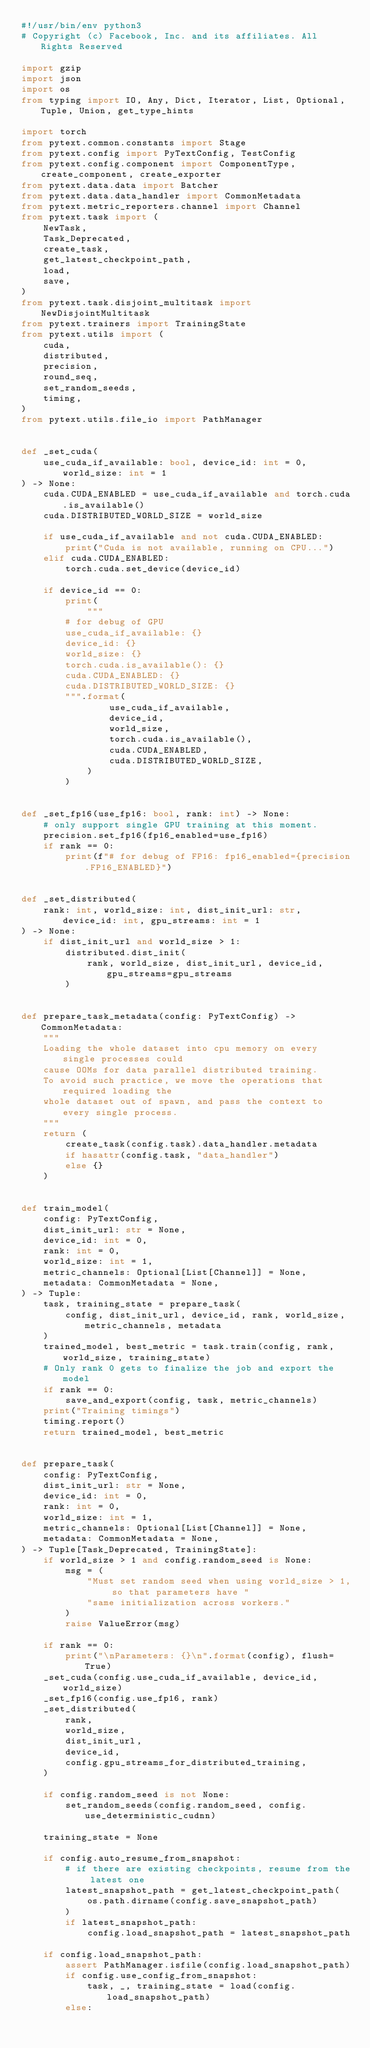Convert code to text. <code><loc_0><loc_0><loc_500><loc_500><_Python_>#!/usr/bin/env python3
# Copyright (c) Facebook, Inc. and its affiliates. All Rights Reserved

import gzip
import json
import os
from typing import IO, Any, Dict, Iterator, List, Optional, Tuple, Union, get_type_hints

import torch
from pytext.common.constants import Stage
from pytext.config import PyTextConfig, TestConfig
from pytext.config.component import ComponentType, create_component, create_exporter
from pytext.data.data import Batcher
from pytext.data.data_handler import CommonMetadata
from pytext.metric_reporters.channel import Channel
from pytext.task import (
    NewTask,
    Task_Deprecated,
    create_task,
    get_latest_checkpoint_path,
    load,
    save,
)
from pytext.task.disjoint_multitask import NewDisjointMultitask
from pytext.trainers import TrainingState
from pytext.utils import (
    cuda,
    distributed,
    precision,
    round_seq,
    set_random_seeds,
    timing,
)
from pytext.utils.file_io import PathManager


def _set_cuda(
    use_cuda_if_available: bool, device_id: int = 0, world_size: int = 1
) -> None:
    cuda.CUDA_ENABLED = use_cuda_if_available and torch.cuda.is_available()
    cuda.DISTRIBUTED_WORLD_SIZE = world_size

    if use_cuda_if_available and not cuda.CUDA_ENABLED:
        print("Cuda is not available, running on CPU...")
    elif cuda.CUDA_ENABLED:
        torch.cuda.set_device(device_id)

    if device_id == 0:
        print(
            """
        # for debug of GPU
        use_cuda_if_available: {}
        device_id: {}
        world_size: {}
        torch.cuda.is_available(): {}
        cuda.CUDA_ENABLED: {}
        cuda.DISTRIBUTED_WORLD_SIZE: {}
        """.format(
                use_cuda_if_available,
                device_id,
                world_size,
                torch.cuda.is_available(),
                cuda.CUDA_ENABLED,
                cuda.DISTRIBUTED_WORLD_SIZE,
            )
        )


def _set_fp16(use_fp16: bool, rank: int) -> None:
    # only support single GPU training at this moment.
    precision.set_fp16(fp16_enabled=use_fp16)
    if rank == 0:
        print(f"# for debug of FP16: fp16_enabled={precision.FP16_ENABLED}")


def _set_distributed(
    rank: int, world_size: int, dist_init_url: str, device_id: int, gpu_streams: int = 1
) -> None:
    if dist_init_url and world_size > 1:
        distributed.dist_init(
            rank, world_size, dist_init_url, device_id, gpu_streams=gpu_streams
        )


def prepare_task_metadata(config: PyTextConfig) -> CommonMetadata:
    """
    Loading the whole dataset into cpu memory on every single processes could
    cause OOMs for data parallel distributed training.
    To avoid such practice, we move the operations that required loading the
    whole dataset out of spawn, and pass the context to every single process.
    """
    return (
        create_task(config.task).data_handler.metadata
        if hasattr(config.task, "data_handler")
        else {}
    )


def train_model(
    config: PyTextConfig,
    dist_init_url: str = None,
    device_id: int = 0,
    rank: int = 0,
    world_size: int = 1,
    metric_channels: Optional[List[Channel]] = None,
    metadata: CommonMetadata = None,
) -> Tuple:
    task, training_state = prepare_task(
        config, dist_init_url, device_id, rank, world_size, metric_channels, metadata
    )
    trained_model, best_metric = task.train(config, rank, world_size, training_state)
    # Only rank 0 gets to finalize the job and export the model
    if rank == 0:
        save_and_export(config, task, metric_channels)
    print("Training timings")
    timing.report()
    return trained_model, best_metric


def prepare_task(
    config: PyTextConfig,
    dist_init_url: str = None,
    device_id: int = 0,
    rank: int = 0,
    world_size: int = 1,
    metric_channels: Optional[List[Channel]] = None,
    metadata: CommonMetadata = None,
) -> Tuple[Task_Deprecated, TrainingState]:
    if world_size > 1 and config.random_seed is None:
        msg = (
            "Must set random seed when using world_size > 1, so that parameters have "
            "same initialization across workers."
        )
        raise ValueError(msg)

    if rank == 0:
        print("\nParameters: {}\n".format(config), flush=True)
    _set_cuda(config.use_cuda_if_available, device_id, world_size)
    _set_fp16(config.use_fp16, rank)
    _set_distributed(
        rank,
        world_size,
        dist_init_url,
        device_id,
        config.gpu_streams_for_distributed_training,
    )

    if config.random_seed is not None:
        set_random_seeds(config.random_seed, config.use_deterministic_cudnn)

    training_state = None

    if config.auto_resume_from_snapshot:
        # if there are existing checkpoints, resume from the latest one
        latest_snapshot_path = get_latest_checkpoint_path(
            os.path.dirname(config.save_snapshot_path)
        )
        if latest_snapshot_path:
            config.load_snapshot_path = latest_snapshot_path

    if config.load_snapshot_path:
        assert PathManager.isfile(config.load_snapshot_path)
        if config.use_config_from_snapshot:
            task, _, training_state = load(config.load_snapshot_path)
        else:</code> 